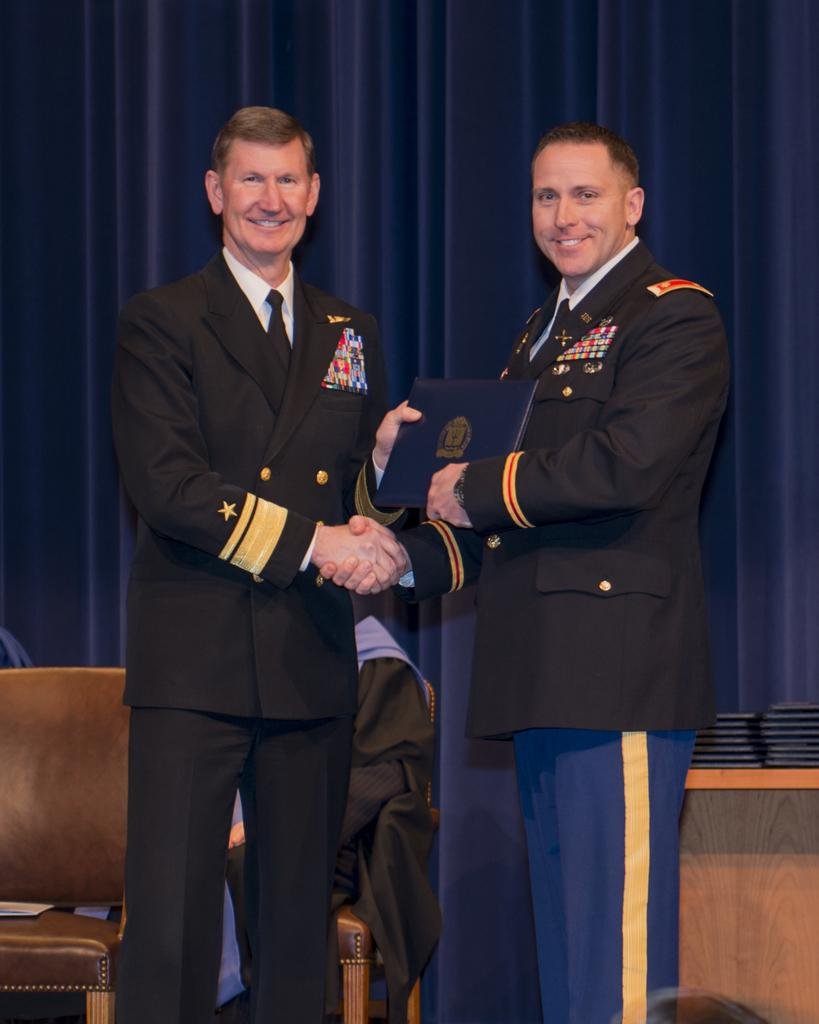What type of figures are present in the image? There are two Army Men in the image. What are the Army Men doing in the image? The Army Men are standing and shaking hands. What expressions do the Army Men have in the image? Both Army Men are smiling. What can be seen in the background of the image? There is a blue color curtain in the background of the image. What type of patch is visible on the Army Men's uniforms in the image? There is no patch visible on the Army Men's uniforms in the image. What type of brass instrument is being played by the Army Men in the image? There are no brass instruments present in the image; the Army Men are shaking hands. 